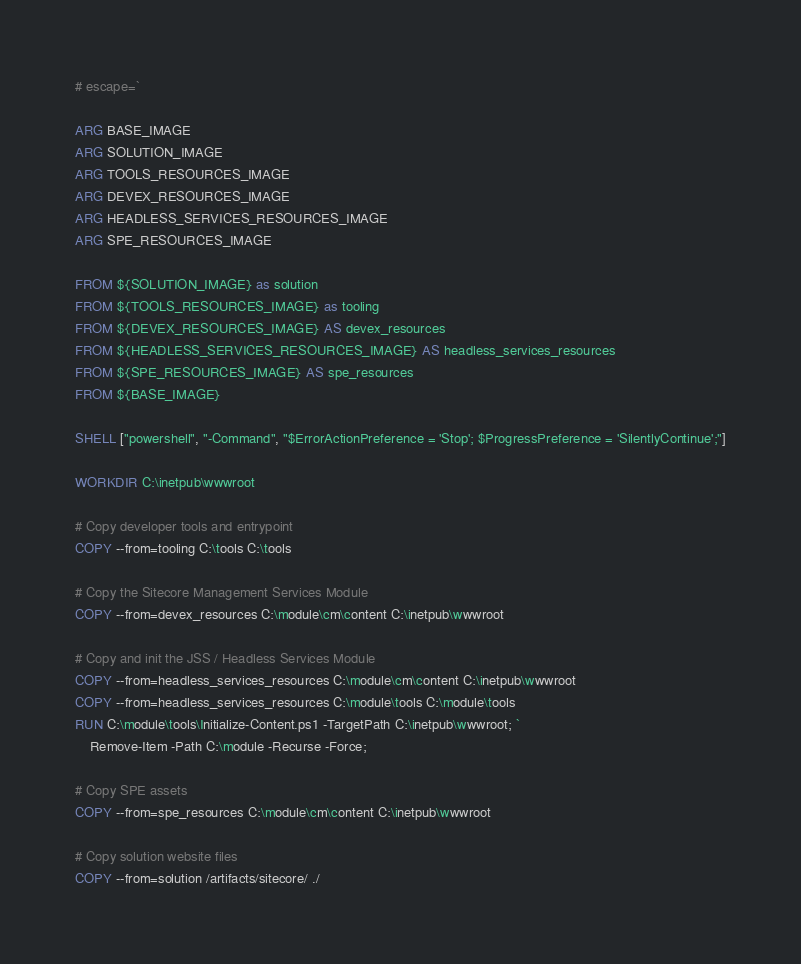<code> <loc_0><loc_0><loc_500><loc_500><_Dockerfile_># escape=`

ARG BASE_IMAGE
ARG SOLUTION_IMAGE
ARG TOOLS_RESOURCES_IMAGE
ARG DEVEX_RESOURCES_IMAGE
ARG HEADLESS_SERVICES_RESOURCES_IMAGE
ARG SPE_RESOURCES_IMAGE

FROM ${SOLUTION_IMAGE} as solution
FROM ${TOOLS_RESOURCES_IMAGE} as tooling
FROM ${DEVEX_RESOURCES_IMAGE} AS devex_resources
FROM ${HEADLESS_SERVICES_RESOURCES_IMAGE} AS headless_services_resources
FROM ${SPE_RESOURCES_IMAGE} AS spe_resources
FROM ${BASE_IMAGE}

SHELL ["powershell", "-Command", "$ErrorActionPreference = 'Stop'; $ProgressPreference = 'SilentlyContinue';"]

WORKDIR C:\inetpub\wwwroot

# Copy developer tools and entrypoint
COPY --from=tooling C:\tools C:\tools

# Copy the Sitecore Management Services Module
COPY --from=devex_resources C:\module\cm\content C:\inetpub\wwwroot

# Copy and init the JSS / Headless Services Module
COPY --from=headless_services_resources C:\module\cm\content C:\inetpub\wwwroot
COPY --from=headless_services_resources C:\module\tools C:\module\tools
RUN C:\module\tools\Initialize-Content.ps1 -TargetPath C:\inetpub\wwwroot; `
    Remove-Item -Path C:\module -Recurse -Force;

# Copy SPE assets
COPY --from=spe_resources C:\module\cm\content C:\inetpub\wwwroot

# Copy solution website files
COPY --from=solution /artifacts/sitecore/ ./</code> 